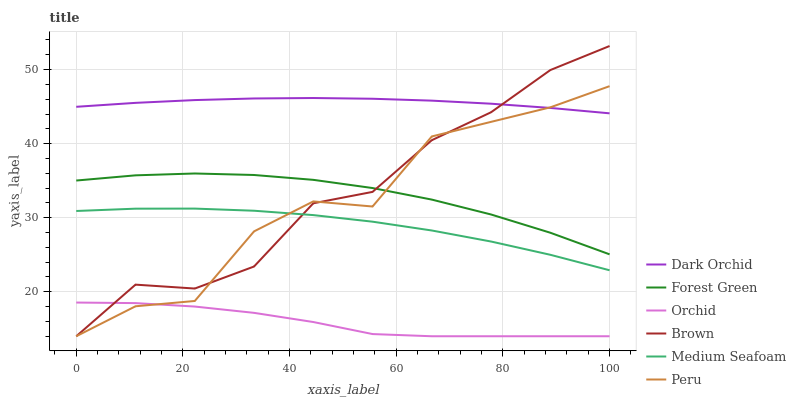Does Orchid have the minimum area under the curve?
Answer yes or no. Yes. Does Dark Orchid have the maximum area under the curve?
Answer yes or no. Yes. Does Forest Green have the minimum area under the curve?
Answer yes or no. No. Does Forest Green have the maximum area under the curve?
Answer yes or no. No. Is Dark Orchid the smoothest?
Answer yes or no. Yes. Is Peru the roughest?
Answer yes or no. Yes. Is Forest Green the smoothest?
Answer yes or no. No. Is Forest Green the roughest?
Answer yes or no. No. Does Brown have the lowest value?
Answer yes or no. Yes. Does Forest Green have the lowest value?
Answer yes or no. No. Does Brown have the highest value?
Answer yes or no. Yes. Does Dark Orchid have the highest value?
Answer yes or no. No. Is Medium Seafoam less than Forest Green?
Answer yes or no. Yes. Is Forest Green greater than Orchid?
Answer yes or no. Yes. Does Brown intersect Medium Seafoam?
Answer yes or no. Yes. Is Brown less than Medium Seafoam?
Answer yes or no. No. Is Brown greater than Medium Seafoam?
Answer yes or no. No. Does Medium Seafoam intersect Forest Green?
Answer yes or no. No. 